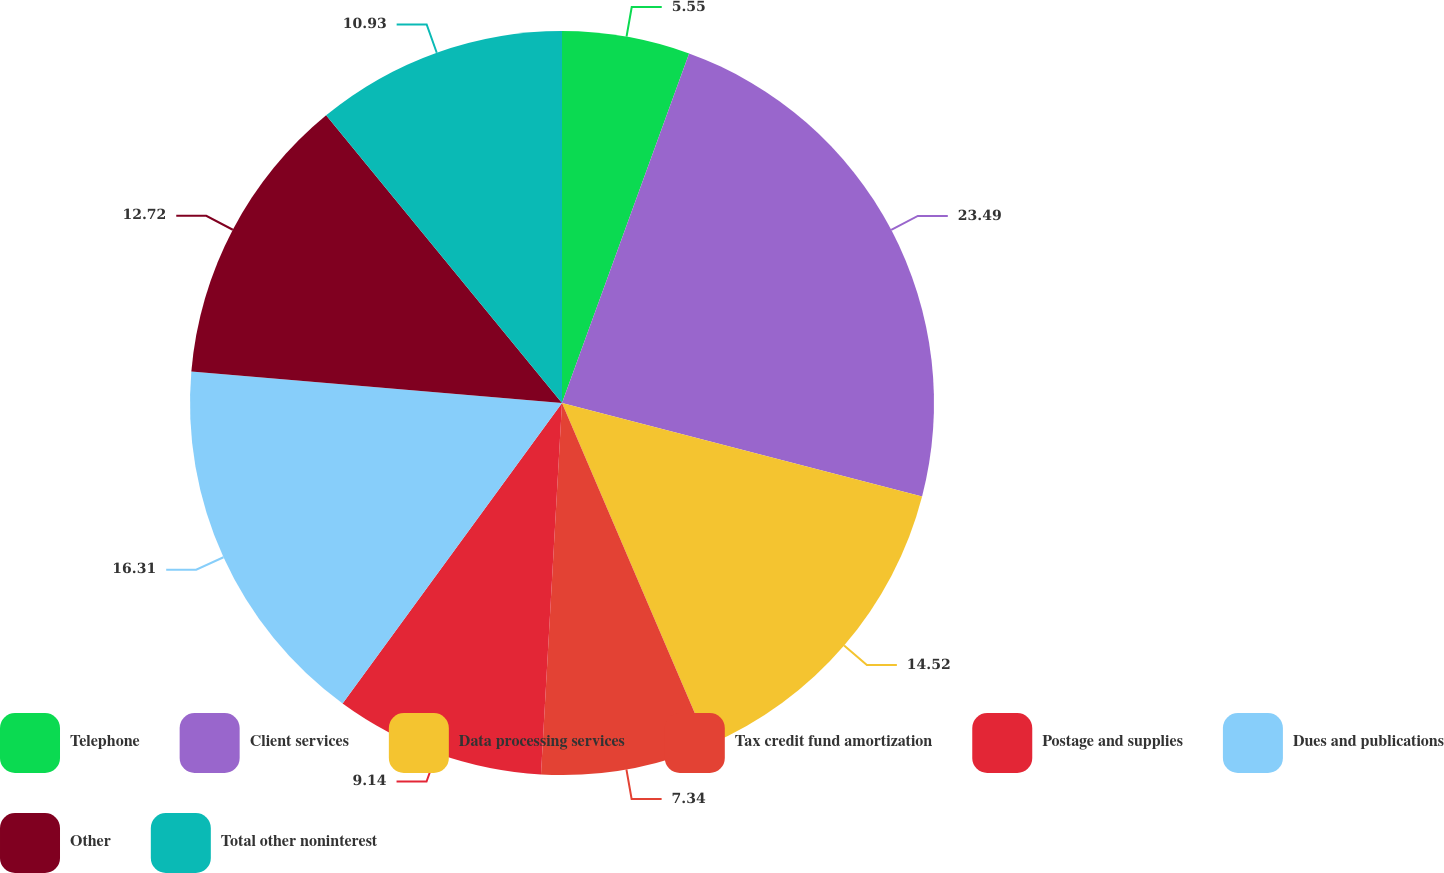Convert chart to OTSL. <chart><loc_0><loc_0><loc_500><loc_500><pie_chart><fcel>Telephone<fcel>Client services<fcel>Data processing services<fcel>Tax credit fund amortization<fcel>Postage and supplies<fcel>Dues and publications<fcel>Other<fcel>Total other noninterest<nl><fcel>5.55%<fcel>23.49%<fcel>14.52%<fcel>7.34%<fcel>9.14%<fcel>16.31%<fcel>12.72%<fcel>10.93%<nl></chart> 